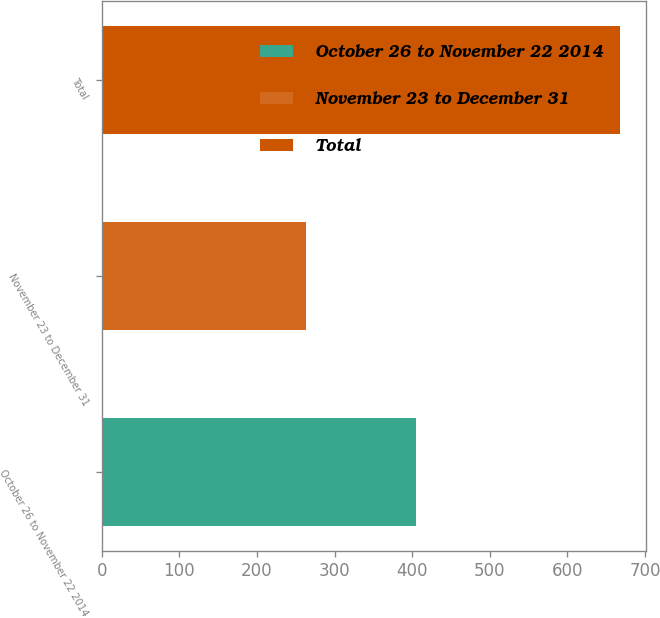Convert chart to OTSL. <chart><loc_0><loc_0><loc_500><loc_500><bar_chart><fcel>October 26 to November 22 2014<fcel>November 23 to December 31<fcel>Total<nl><fcel>405<fcel>263<fcel>668<nl></chart> 